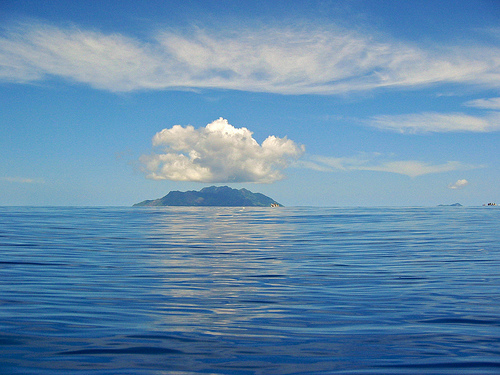<image>
Is the cloud to the left of the island? No. The cloud is not to the left of the island. From this viewpoint, they have a different horizontal relationship. 